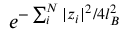<formula> <loc_0><loc_0><loc_500><loc_500>e ^ { - \sum _ { i } ^ { N } | z _ { i } | ^ { 2 } / 4 l _ { B } ^ { 2 } }</formula> 